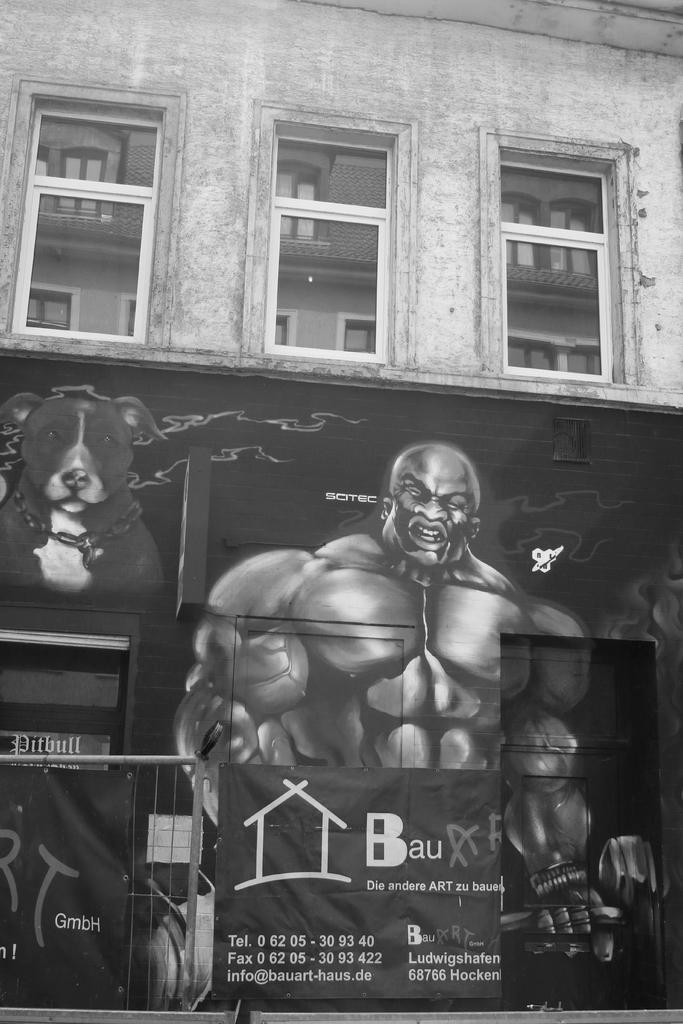How would you summarize this image in a sentence or two? Here we can see a building and windows. On this wall we can see painting of a person and a dog. In front of this building we can see a grill and banners. 